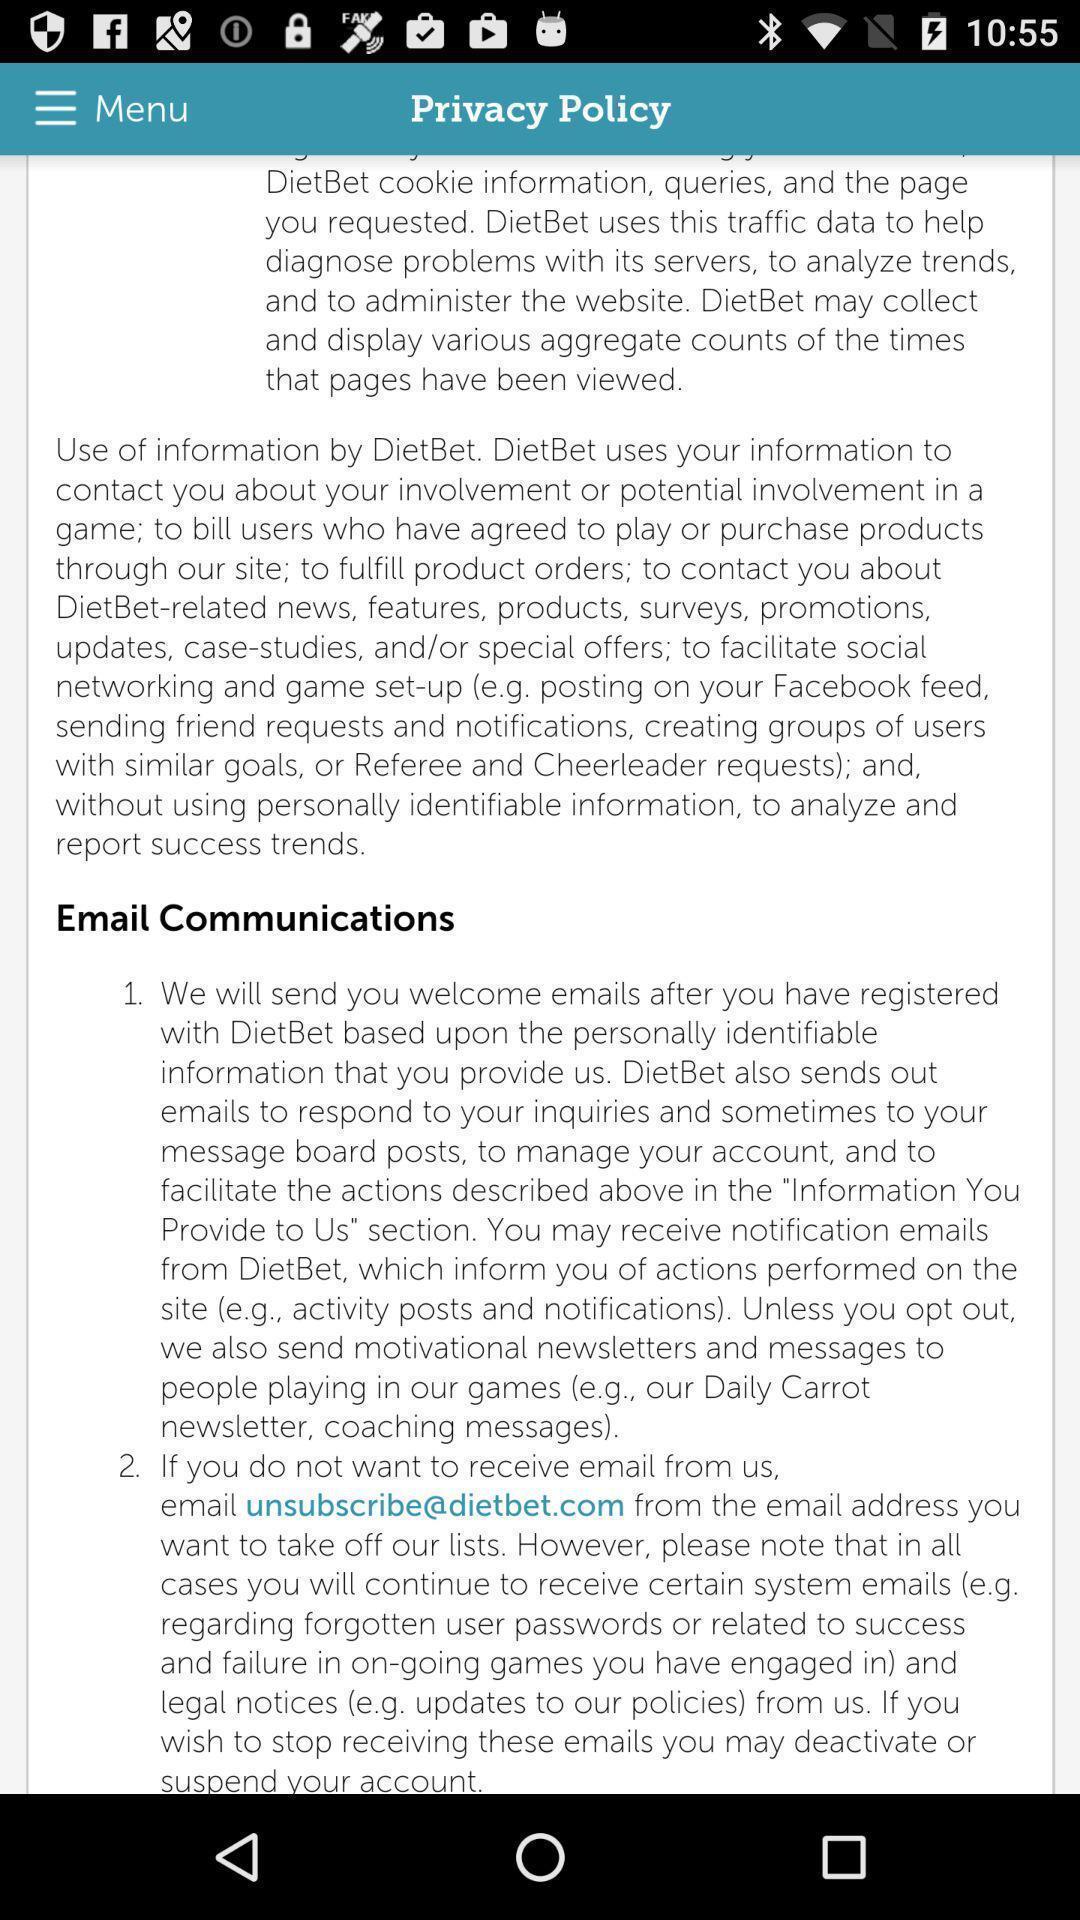Give me a narrative description of this picture. Screen showing a page with policy. 